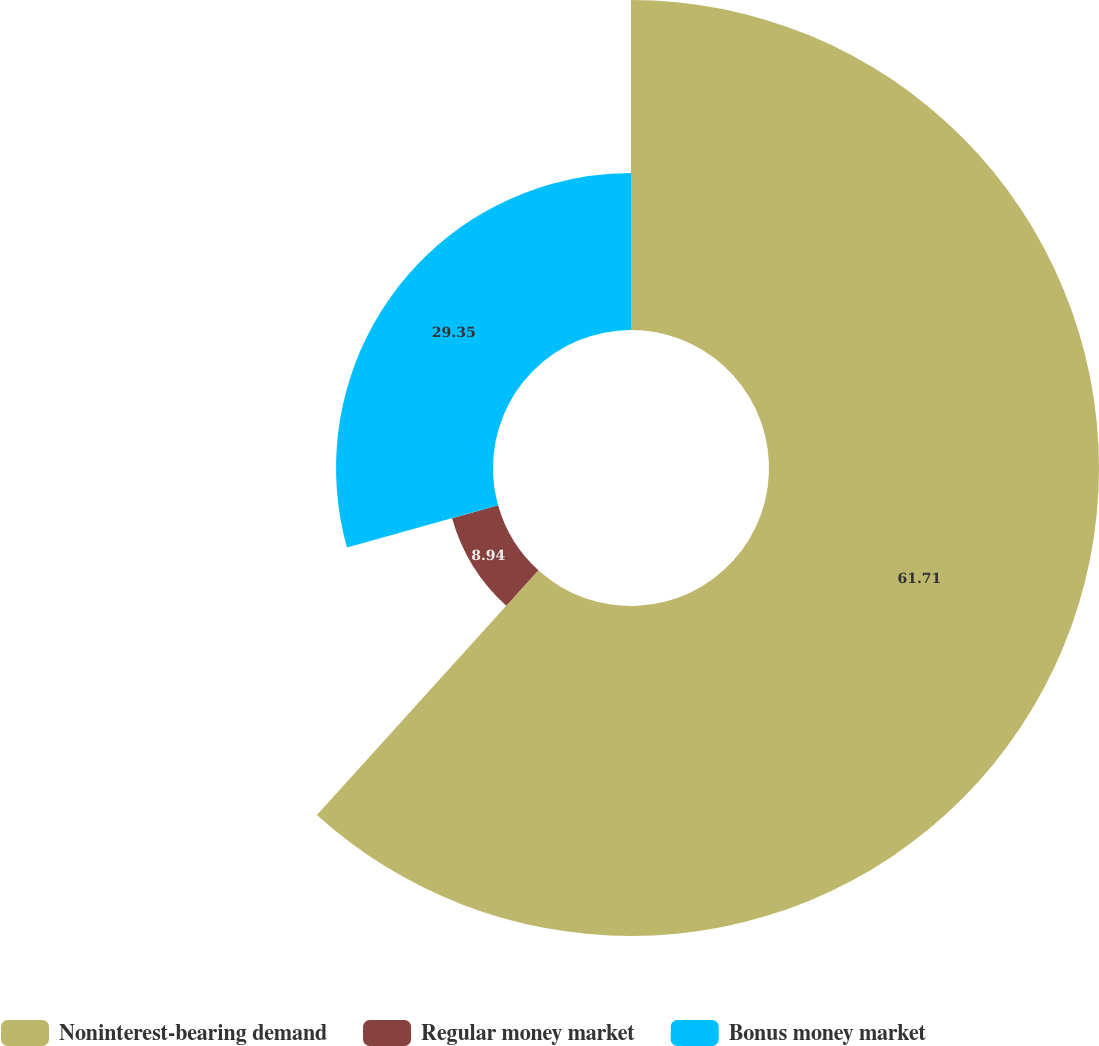Convert chart to OTSL. <chart><loc_0><loc_0><loc_500><loc_500><pie_chart><fcel>Noninterest-bearing demand<fcel>Regular money market<fcel>Bonus money market<nl><fcel>61.71%<fcel>8.94%<fcel>29.35%<nl></chart> 